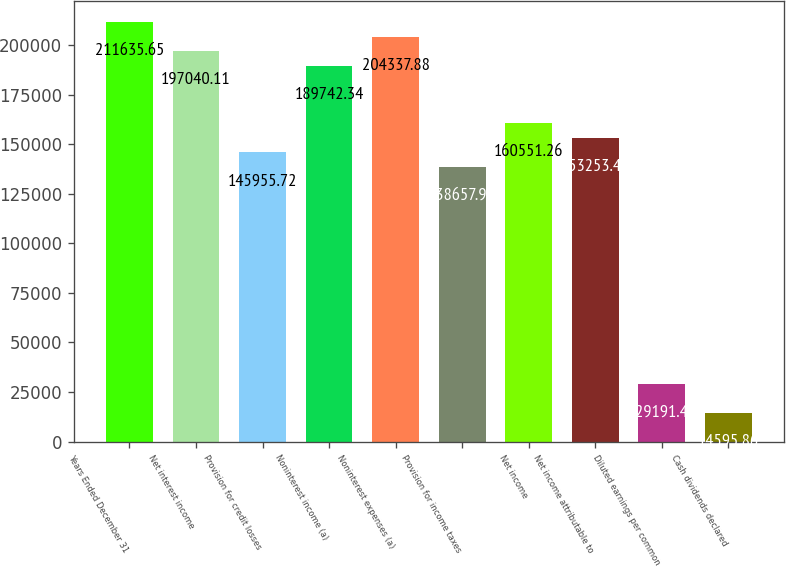Convert chart. <chart><loc_0><loc_0><loc_500><loc_500><bar_chart><fcel>Years Ended December 31<fcel>Net interest income<fcel>Provision for credit losses<fcel>Noninterest income (a)<fcel>Noninterest expenses (a)<fcel>Provision for income taxes<fcel>Net income<fcel>Net income attributable to<fcel>Diluted earnings per common<fcel>Cash dividends declared<nl><fcel>211636<fcel>197040<fcel>145956<fcel>189742<fcel>204338<fcel>138658<fcel>160551<fcel>153253<fcel>29191.4<fcel>14595.9<nl></chart> 